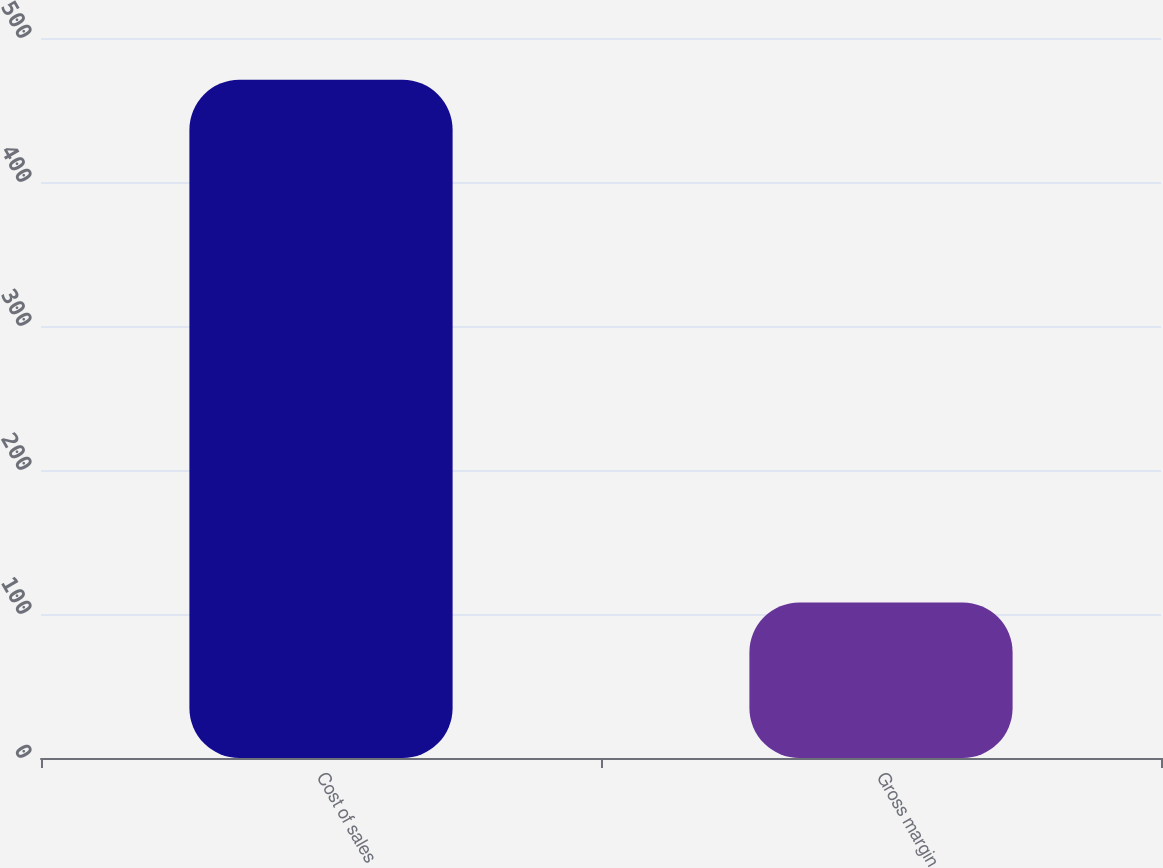Convert chart to OTSL. <chart><loc_0><loc_0><loc_500><loc_500><bar_chart><fcel>Cost of sales<fcel>Gross margin<nl><fcel>471<fcel>108<nl></chart> 